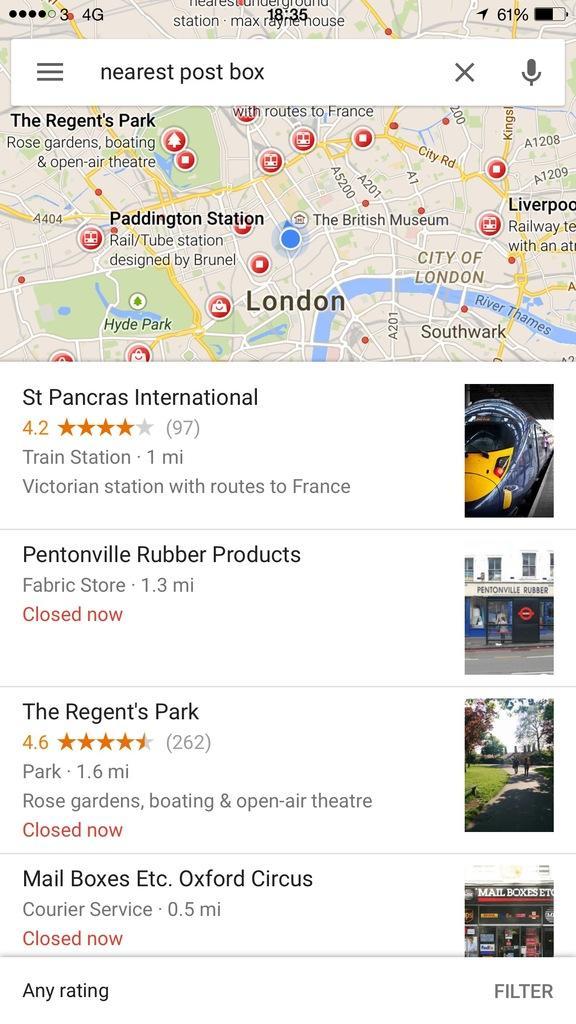Can you describe this image briefly? This is a screenshot of an image. We can see pictures and some text on it. 